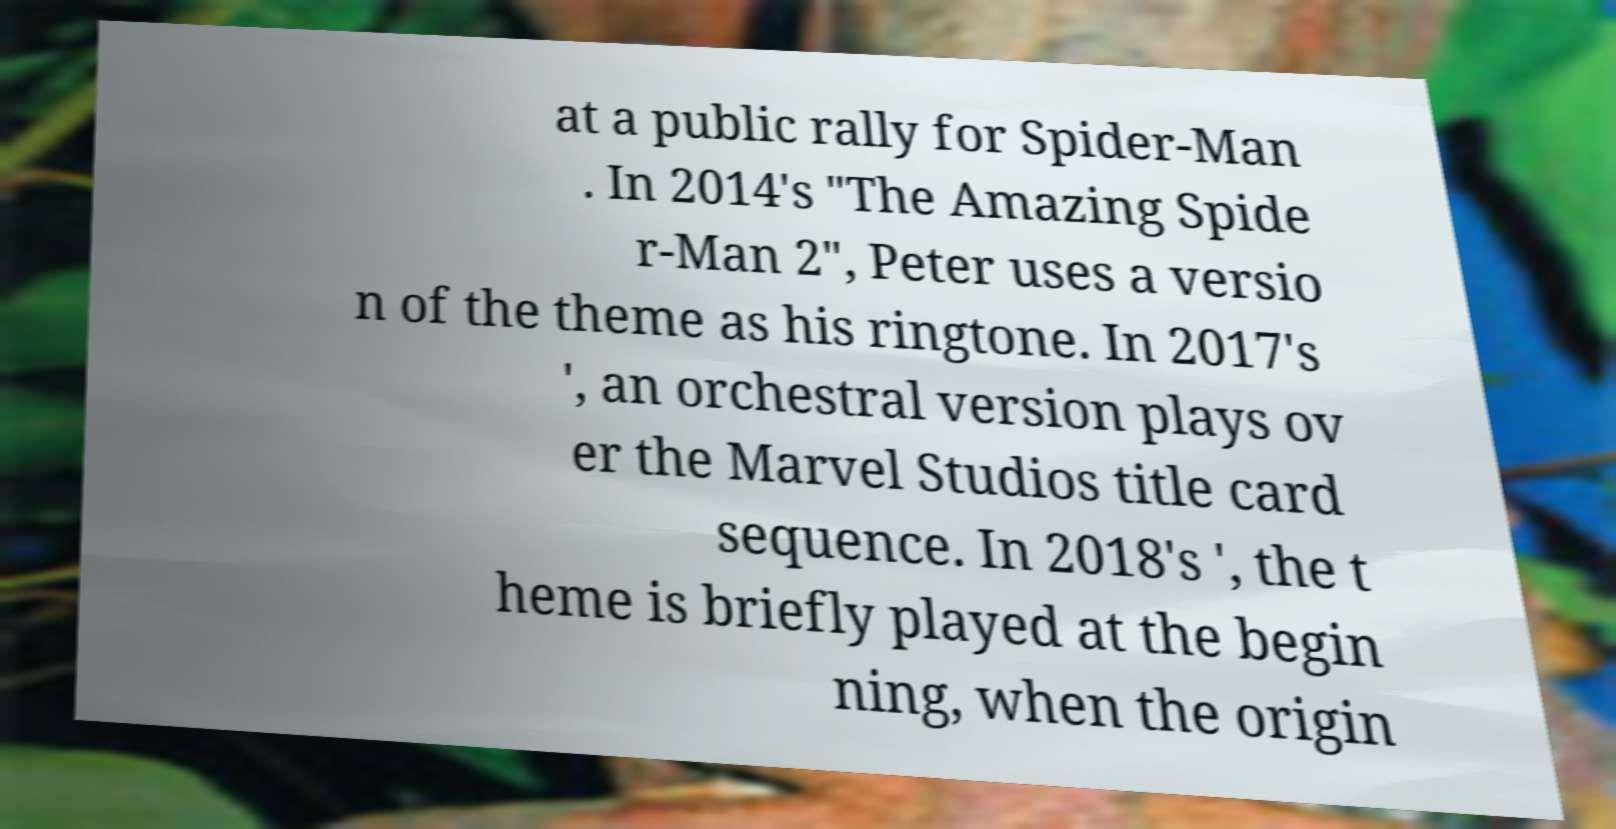There's text embedded in this image that I need extracted. Can you transcribe it verbatim? at a public rally for Spider-Man . In 2014's "The Amazing Spide r-Man 2", Peter uses a versio n of the theme as his ringtone. In 2017's ', an orchestral version plays ov er the Marvel Studios title card sequence. In 2018's ', the t heme is briefly played at the begin ning, when the origin 